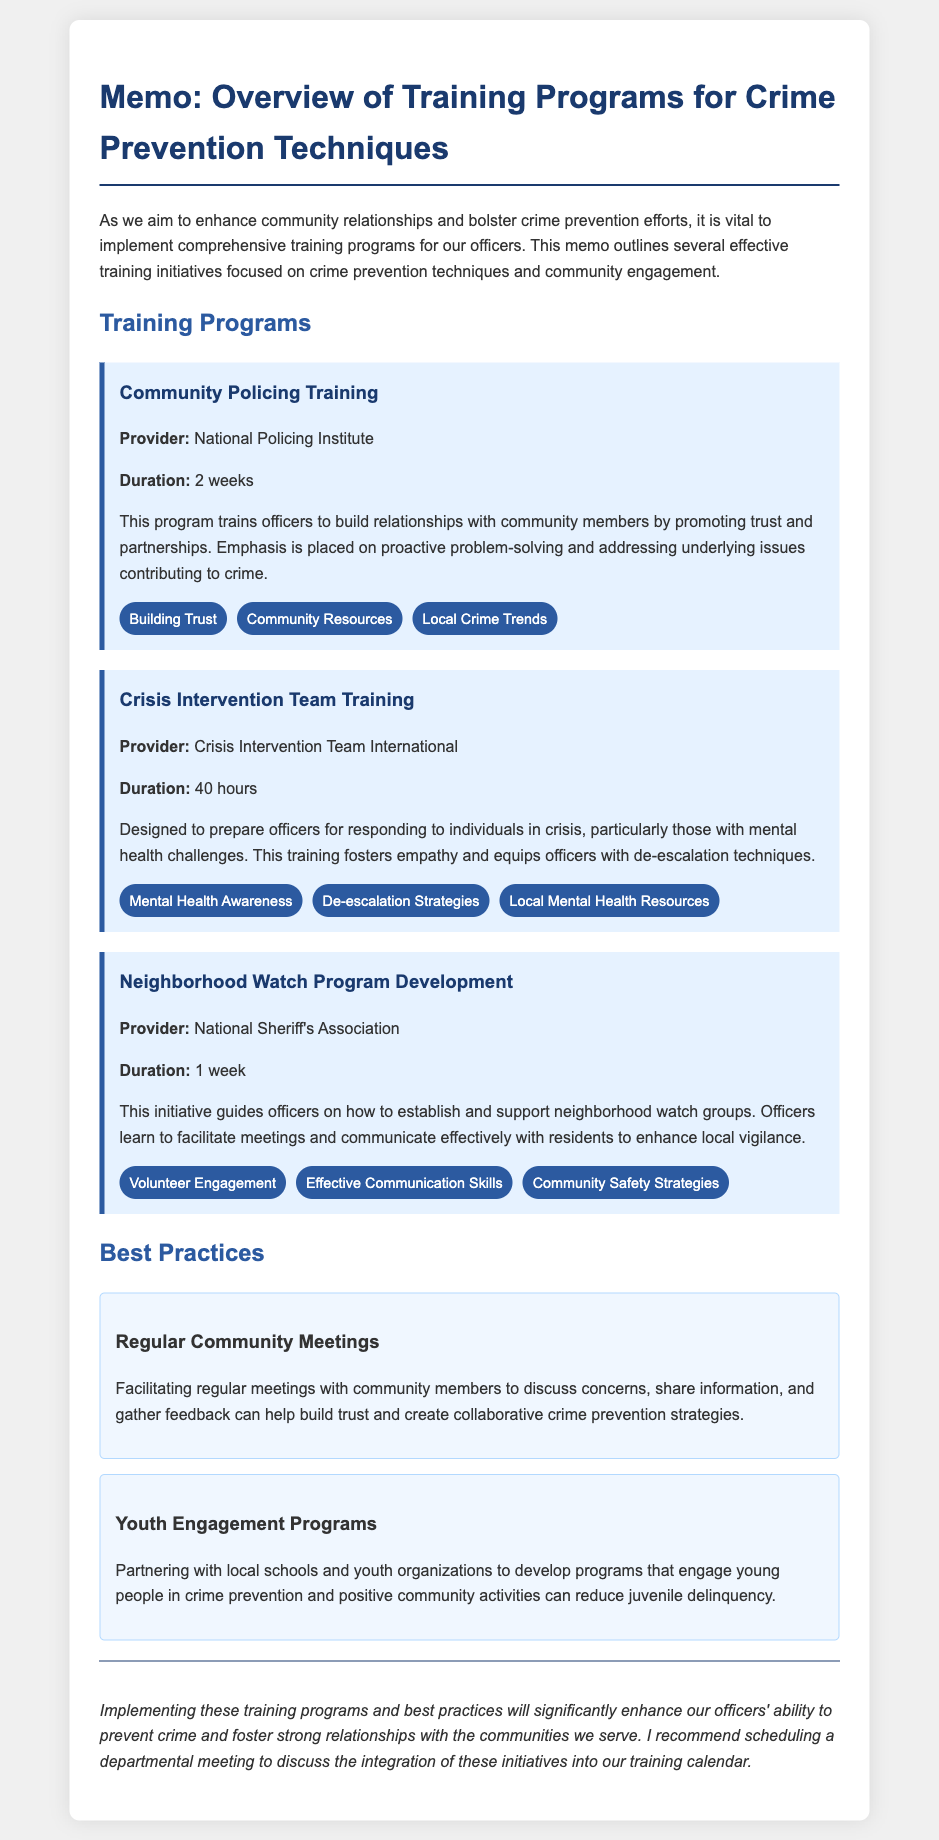What is the title of the memo? The title of the memo is provided at the top of the document, indicating its focus on training programs related to crime prevention.
Answer: Overview of Training Programs for Crime Prevention Techniques How long is the Community Policing Training program? The duration of the Community Policing Training program is stated directly in the document.
Answer: 2 weeks What organization provides Crisis Intervention Team Training? The document lists the organization responsible for providing this training program.
Answer: Crisis Intervention Team International What key topic is emphasized in the Neighborhood Watch Program Development? The document lists multiple key topics for the Neighborhood Watch Program, one of which directly addresses officer responsibilities.
Answer: Volunteer Engagement What is a recommended best practice mentioned in the memo? The memo identifies specific best practices for community engagement and crime prevention.
Answer: Regular Community Meetings How many hours does the Crisis Intervention Team Training last? The document explicitly states the duration of the Crisis Intervention Team Training in hours.
Answer: 40 hours What is the proposed action at the end of the memo? The conclusion of the memo outlines a specific next step to further implement the discussed training programs.
Answer: Scheduling a departmental meeting Which training program focuses on engaging youth? The best practices section includes a program that targets youth involvement in crime prevention efforts.
Answer: Youth Engagement Programs 